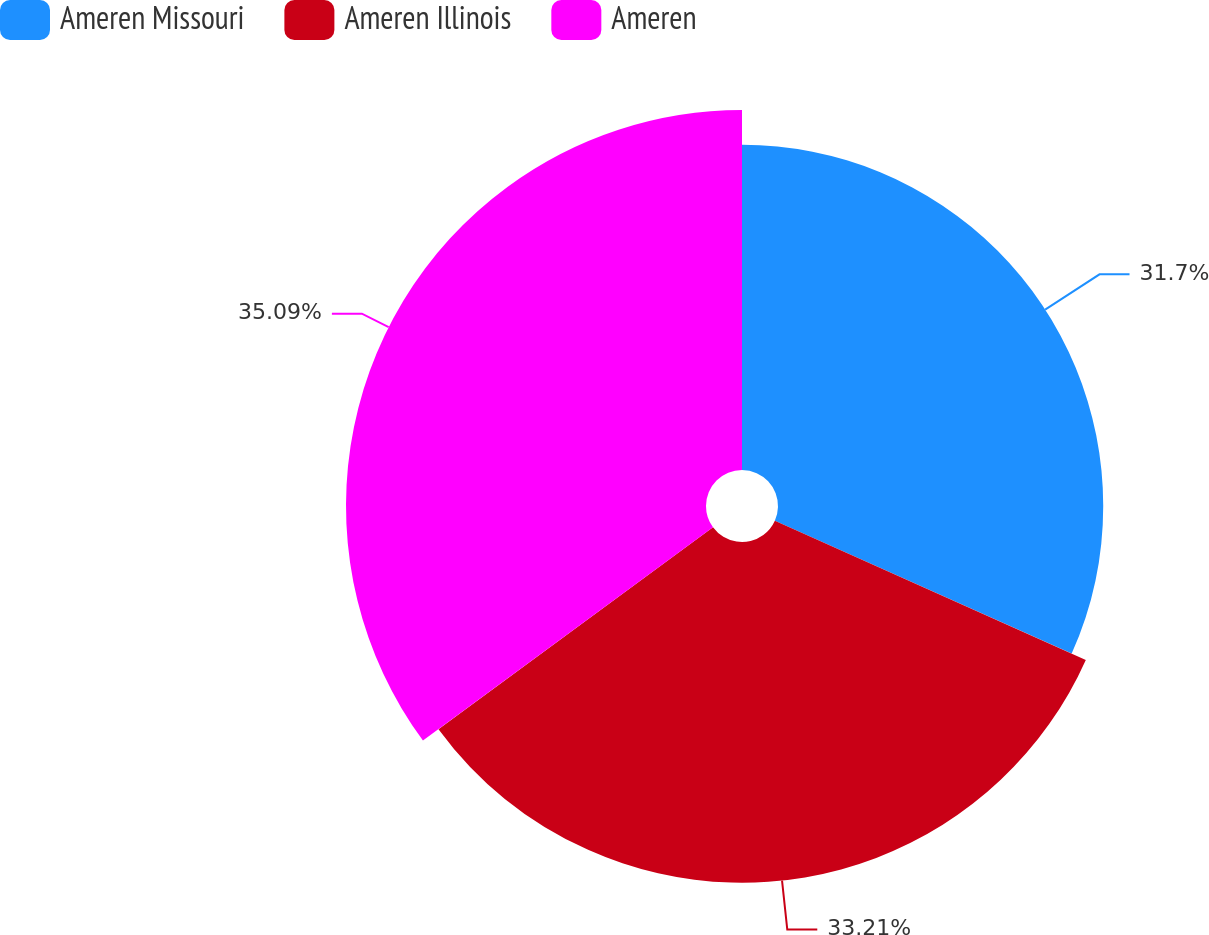<chart> <loc_0><loc_0><loc_500><loc_500><pie_chart><fcel>Ameren Missouri<fcel>Ameren Illinois<fcel>Ameren<nl><fcel>31.7%<fcel>33.21%<fcel>35.09%<nl></chart> 